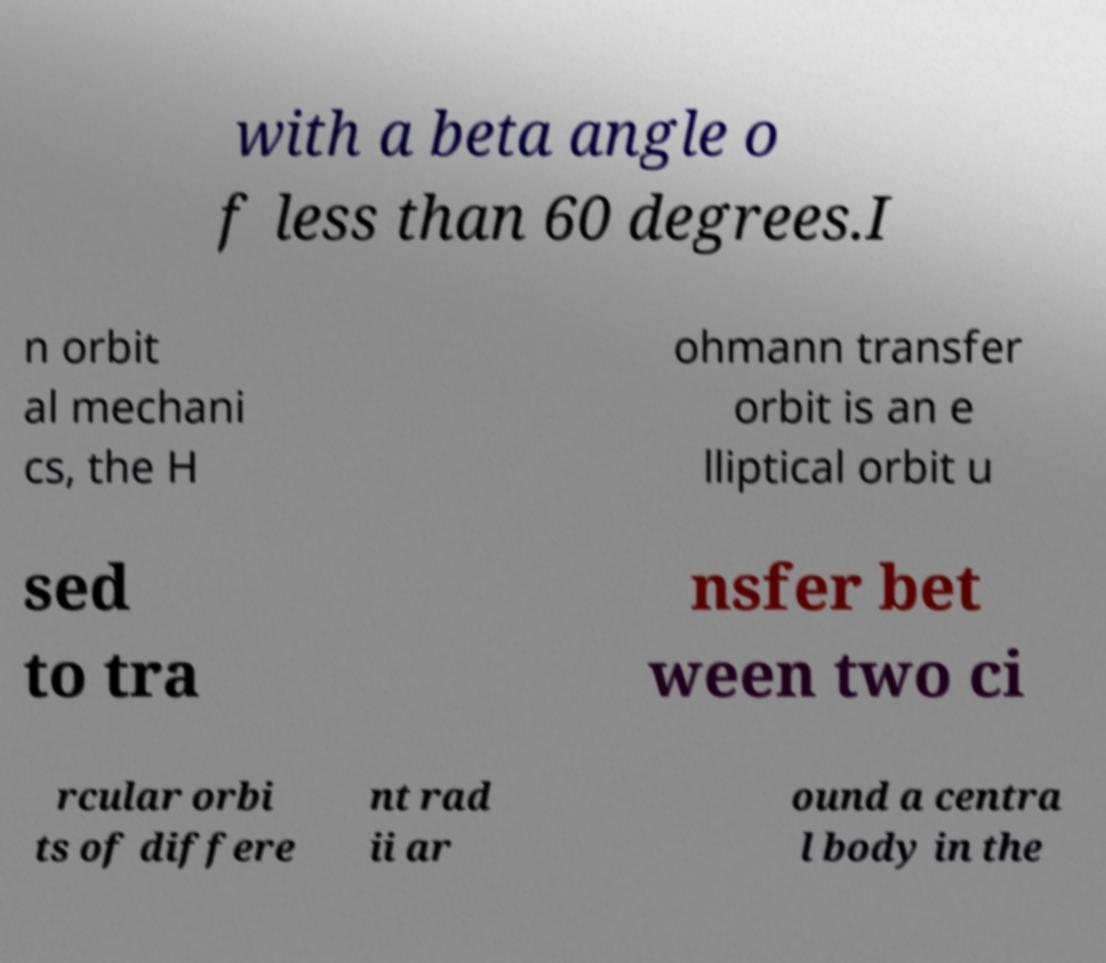Can you read and provide the text displayed in the image?This photo seems to have some interesting text. Can you extract and type it out for me? with a beta angle o f less than 60 degrees.I n orbit al mechani cs, the H ohmann transfer orbit is an e lliptical orbit u sed to tra nsfer bet ween two ci rcular orbi ts of differe nt rad ii ar ound a centra l body in the 